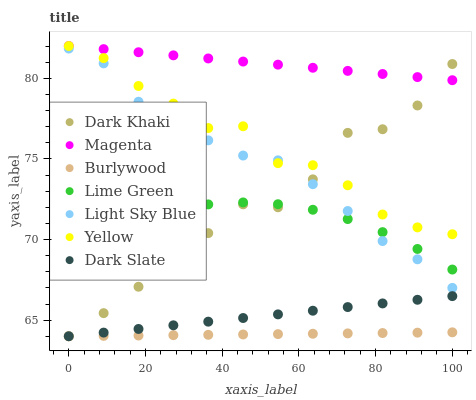Does Burlywood have the minimum area under the curve?
Answer yes or no. Yes. Does Magenta have the maximum area under the curve?
Answer yes or no. Yes. Does Yellow have the minimum area under the curve?
Answer yes or no. No. Does Yellow have the maximum area under the curve?
Answer yes or no. No. Is Magenta the smoothest?
Answer yes or no. Yes. Is Yellow the roughest?
Answer yes or no. Yes. Is Dark Khaki the smoothest?
Answer yes or no. No. Is Dark Khaki the roughest?
Answer yes or no. No. Does Burlywood have the lowest value?
Answer yes or no. Yes. Does Yellow have the lowest value?
Answer yes or no. No. Does Magenta have the highest value?
Answer yes or no. Yes. Does Dark Khaki have the highest value?
Answer yes or no. No. Is Dark Slate less than Yellow?
Answer yes or no. Yes. Is Lime Green greater than Dark Slate?
Answer yes or no. Yes. Does Light Sky Blue intersect Yellow?
Answer yes or no. Yes. Is Light Sky Blue less than Yellow?
Answer yes or no. No. Is Light Sky Blue greater than Yellow?
Answer yes or no. No. Does Dark Slate intersect Yellow?
Answer yes or no. No. 